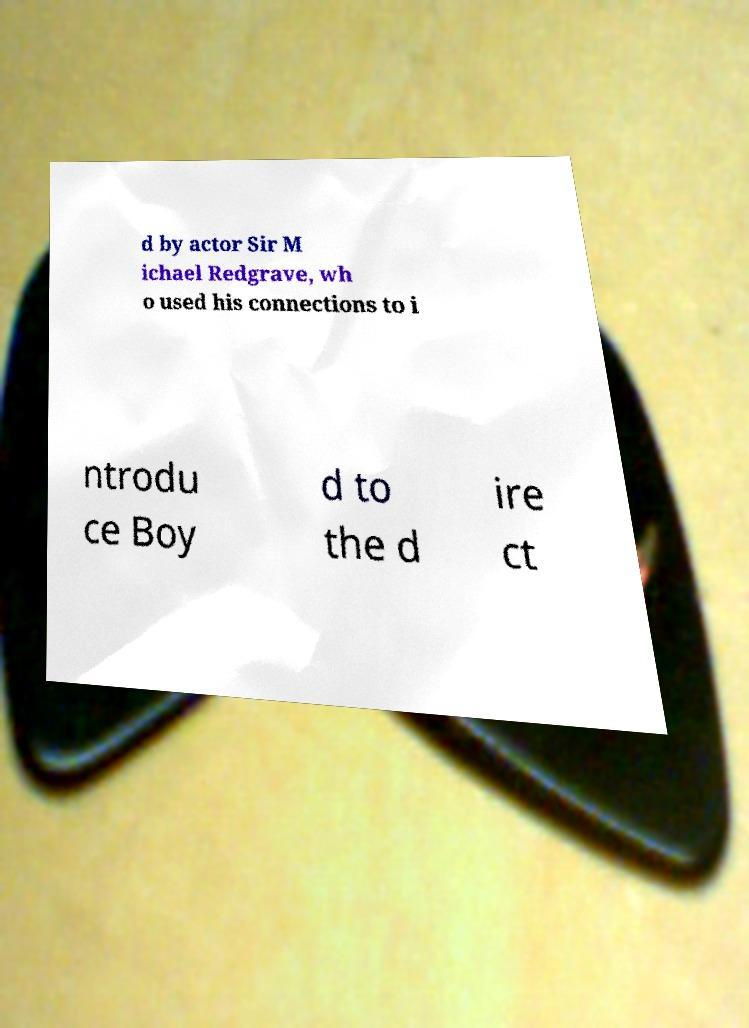I need the written content from this picture converted into text. Can you do that? d by actor Sir M ichael Redgrave, wh o used his connections to i ntrodu ce Boy d to the d ire ct 